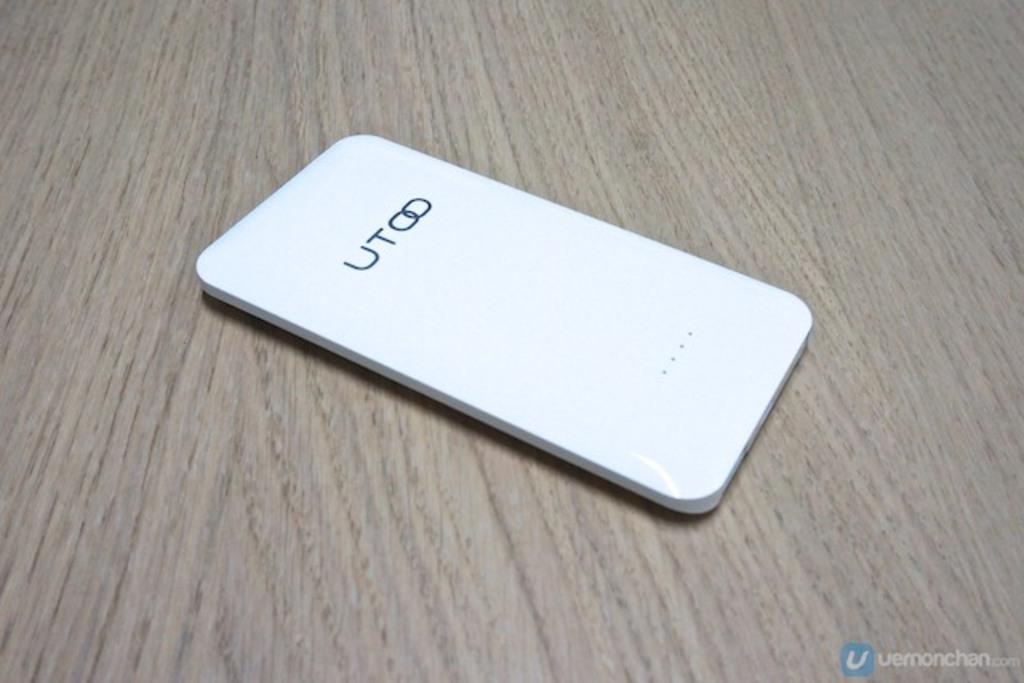What is the name of this phone?
Your answer should be compact. Utoo. 